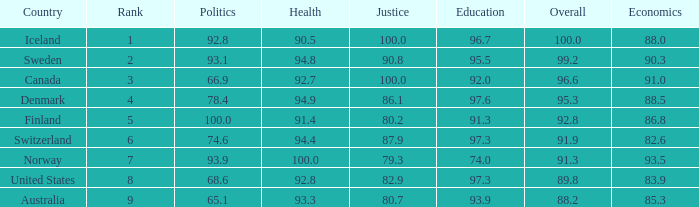What's the country with health being 91.4 Finland. 